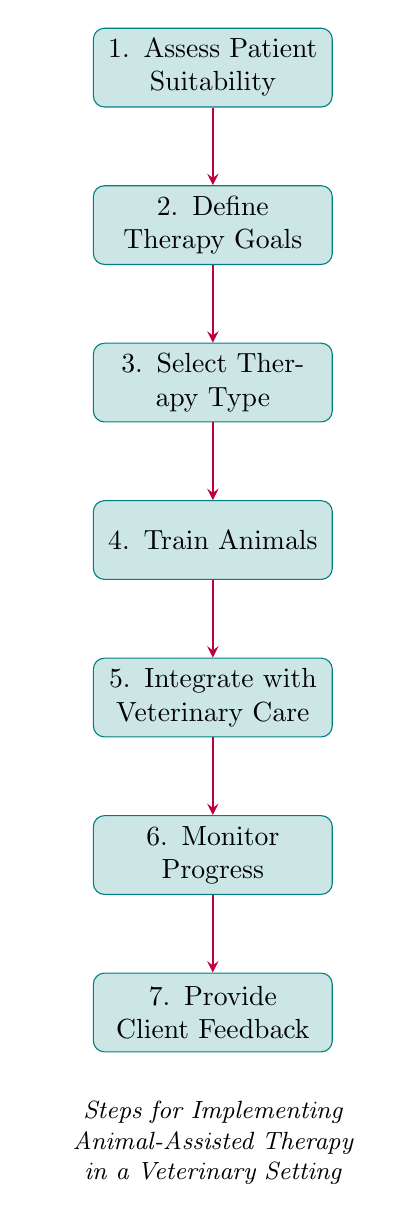What is the first step in the process? The first step in the flow chart is "Assess Patient Suitability," as indicated at the top of the diagram.
Answer: Assess Patient Suitability How many steps are shown in the flow chart? The flow chart contains a total of seven steps, as evidenced by the seven nodes connected in a sequence.
Answer: Seven What is the last step in the flow chart? The last step in the flow chart is "Provide Client Feedback," which is the final node at the bottom of the diagram.
Answer: Provide Client Feedback Which step follows "Train Animals"? The step that follows "Train Animals" in the sequence is "Integrate with Veterinary Care," as shown by the downward arrow directing from the training node to the integration node.
Answer: Integrate with Veterinary Care What is the connection between "Define Therapy Goals" and "Select Therapy Type"? "Define Therapy Goals" is directly connected to "Select Therapy Type," with an arrow indicating that the process moves from setting therapy goals to choosing the type of therapy once goals are established.
Answer: Direct connection What action is taken after monitoring progress? After monitoring progress, the action taken is to "Provide Client Feedback," as indicated by the arrow leading from the monitoring node to the feedback node.
Answer: Provide Client Feedback How does "Integrate with Veterinary Care" relate to the overall process? "Integrate with Veterinary Care" represents a crucial step where therapy sessions are coordinated with the overall veterinary care plan, ensuring that the animal's treatment is comprehensive and synchronized with therapy.
Answer: It coordinates therapy with care Which step is linked directly to "Assess Patient Suitability"? The step linked directly to "Assess Patient Suitability" is "Define Therapy Goals," as indicated by the arrow following the assessment node.
Answer: Define Therapy Goals 